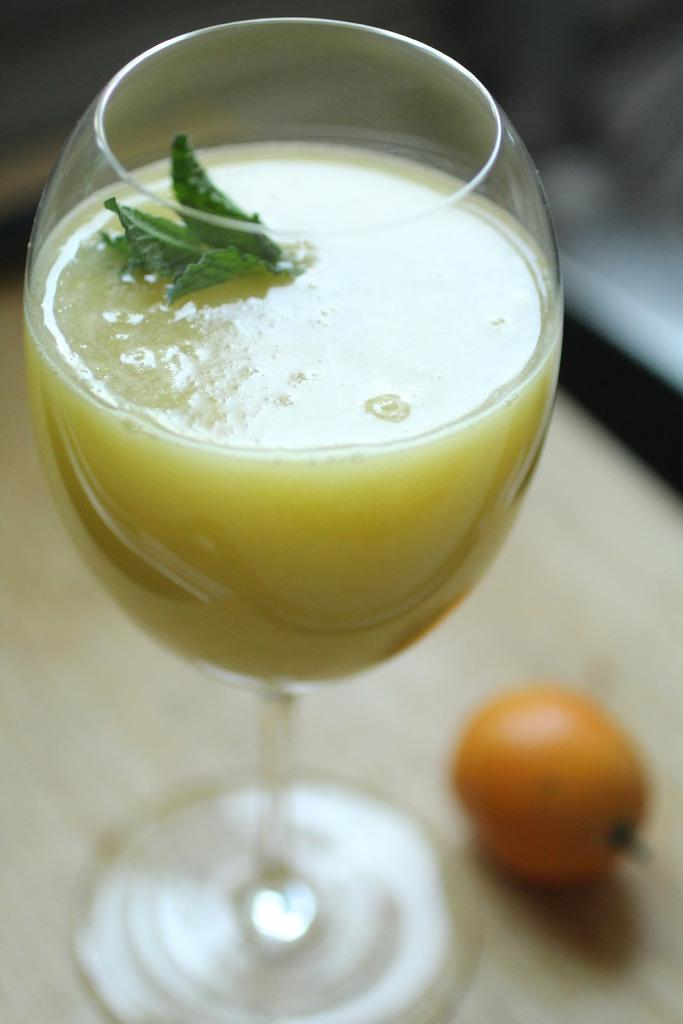Where was the image taken? The image was taken indoors. What furniture is visible in the image? There is a table in the image. What fruit is on the table? There is an orange on the table. What beverage is on the table? There is a glass of juice on the table. What type of underwear is hanging on the wall in the image? There is no underwear present in the image; it only features a table with an orange and a glass of juice. 